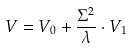<formula> <loc_0><loc_0><loc_500><loc_500>V = V _ { 0 } + \frac { \Sigma ^ { 2 } } { \lambda } \cdot V _ { 1 }</formula> 